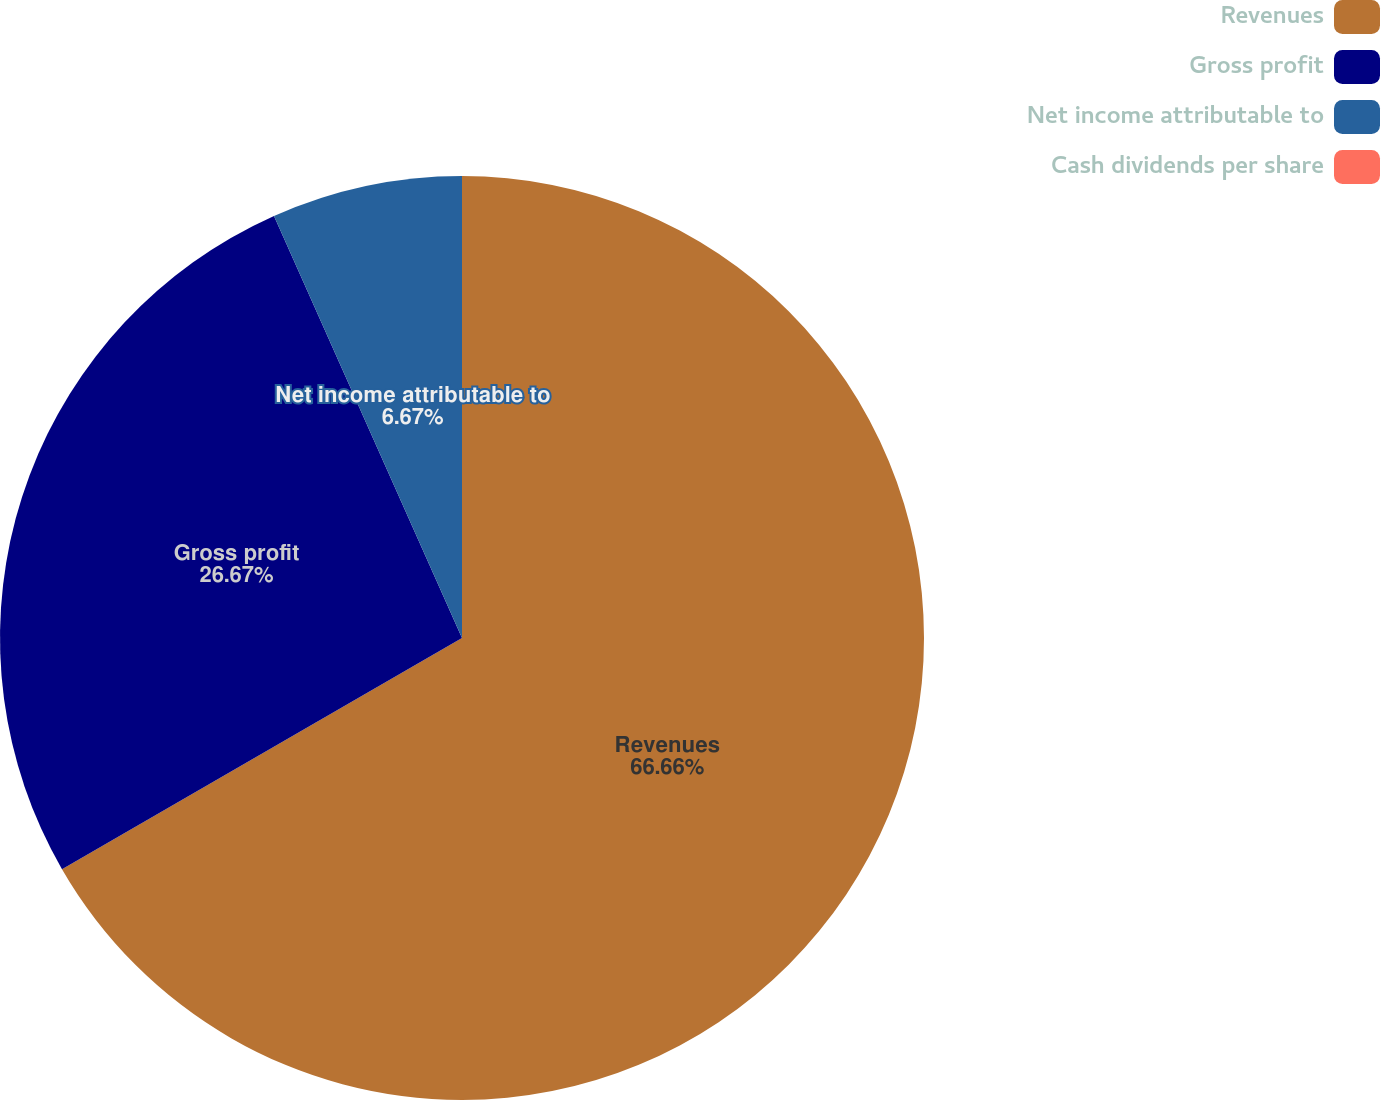<chart> <loc_0><loc_0><loc_500><loc_500><pie_chart><fcel>Revenues<fcel>Gross profit<fcel>Net income attributable to<fcel>Cash dividends per share<nl><fcel>66.66%<fcel>26.67%<fcel>6.67%<fcel>0.0%<nl></chart> 